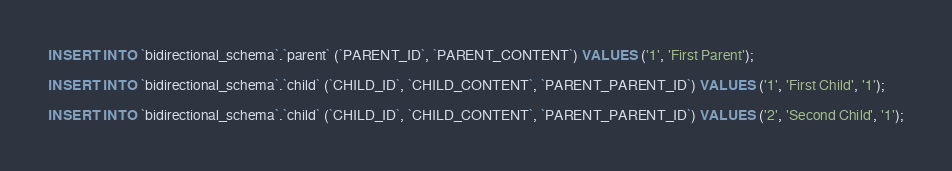Convert code to text. <code><loc_0><loc_0><loc_500><loc_500><_SQL_>INSERT INTO `bidirectional_schema`.`parent` (`PARENT_ID`, `PARENT_CONTENT`) VALUES ('1', 'First Parent');

INSERT INTO `bidirectional_schema`.`child` (`CHILD_ID`, `CHILD_CONTENT`, `PARENT_PARENT_ID`) VALUES ('1', 'First Child', '1');

INSERT INTO `bidirectional_schema`.`child` (`CHILD_ID`, `CHILD_CONTENT`, `PARENT_PARENT_ID`) VALUES ('2', 'Second Child', '1');
</code> 